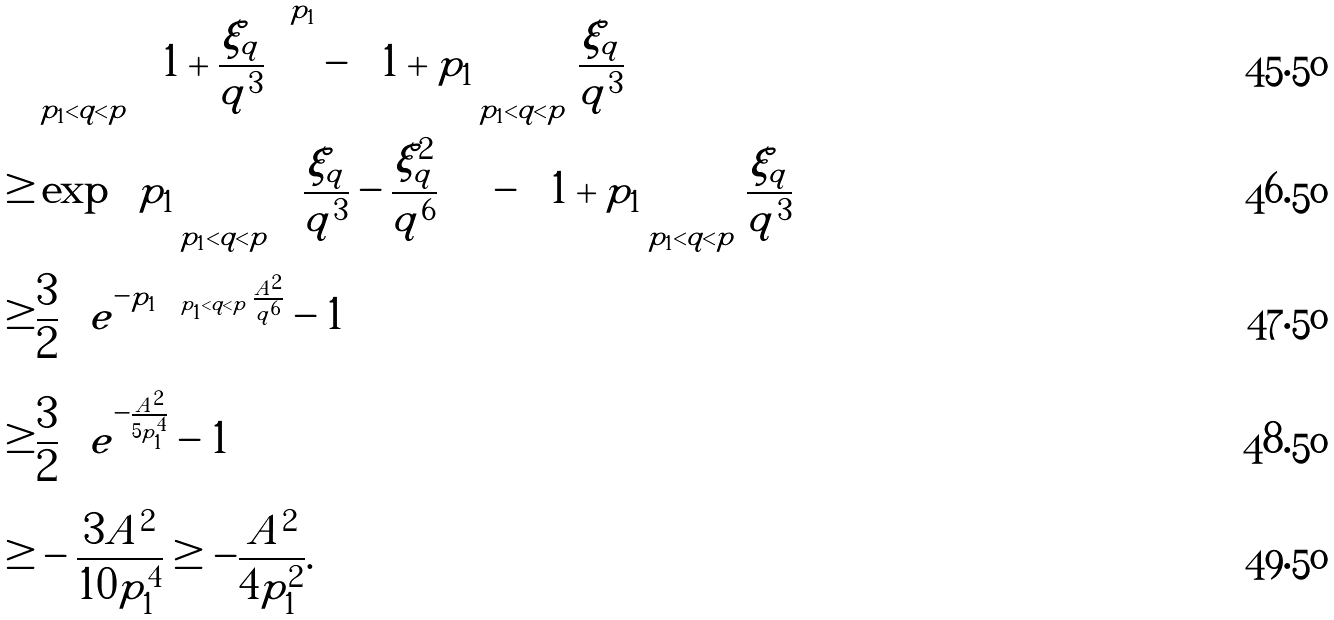<formula> <loc_0><loc_0><loc_500><loc_500>& \prod _ { p _ { 1 } < q < p } \left ( 1 + \frac { \xi _ { q } } { q ^ { 3 } } \right ) ^ { p _ { 1 } } - \left ( 1 + p _ { 1 } \sum _ { p _ { 1 } < q < p } \frac { \xi _ { q } } { q ^ { 3 } } \right ) \\ \geq & \exp \left \{ p _ { 1 } \sum _ { p _ { 1 } < q < p } \left ( \frac { \xi _ { q } } { q ^ { 3 } } - \frac { \xi _ { q } ^ { 2 } } { q ^ { 6 } } \right ) \right \} - \left ( 1 + p _ { 1 } \sum _ { p _ { 1 } < q < p } \frac { \xi _ { q } } { q ^ { 3 } } \right ) \\ \geq & \frac { 3 } { 2 } \left ( e ^ { - p _ { 1 } \sum _ { p _ { 1 } < q < p } \frac { A ^ { 2 } } { q ^ { 6 } } } - 1 \right ) \\ \geq & \frac { 3 } { 2 } \left ( e ^ { - \frac { A ^ { 2 } } { 5 p _ { 1 } ^ { 4 } } } - 1 \right ) \\ \geq & - \frac { 3 A ^ { 2 } } { 1 0 p _ { 1 } ^ { 4 } } \geq - \frac { A ^ { 2 } } { 4 p _ { 1 } ^ { 2 } } .</formula> 